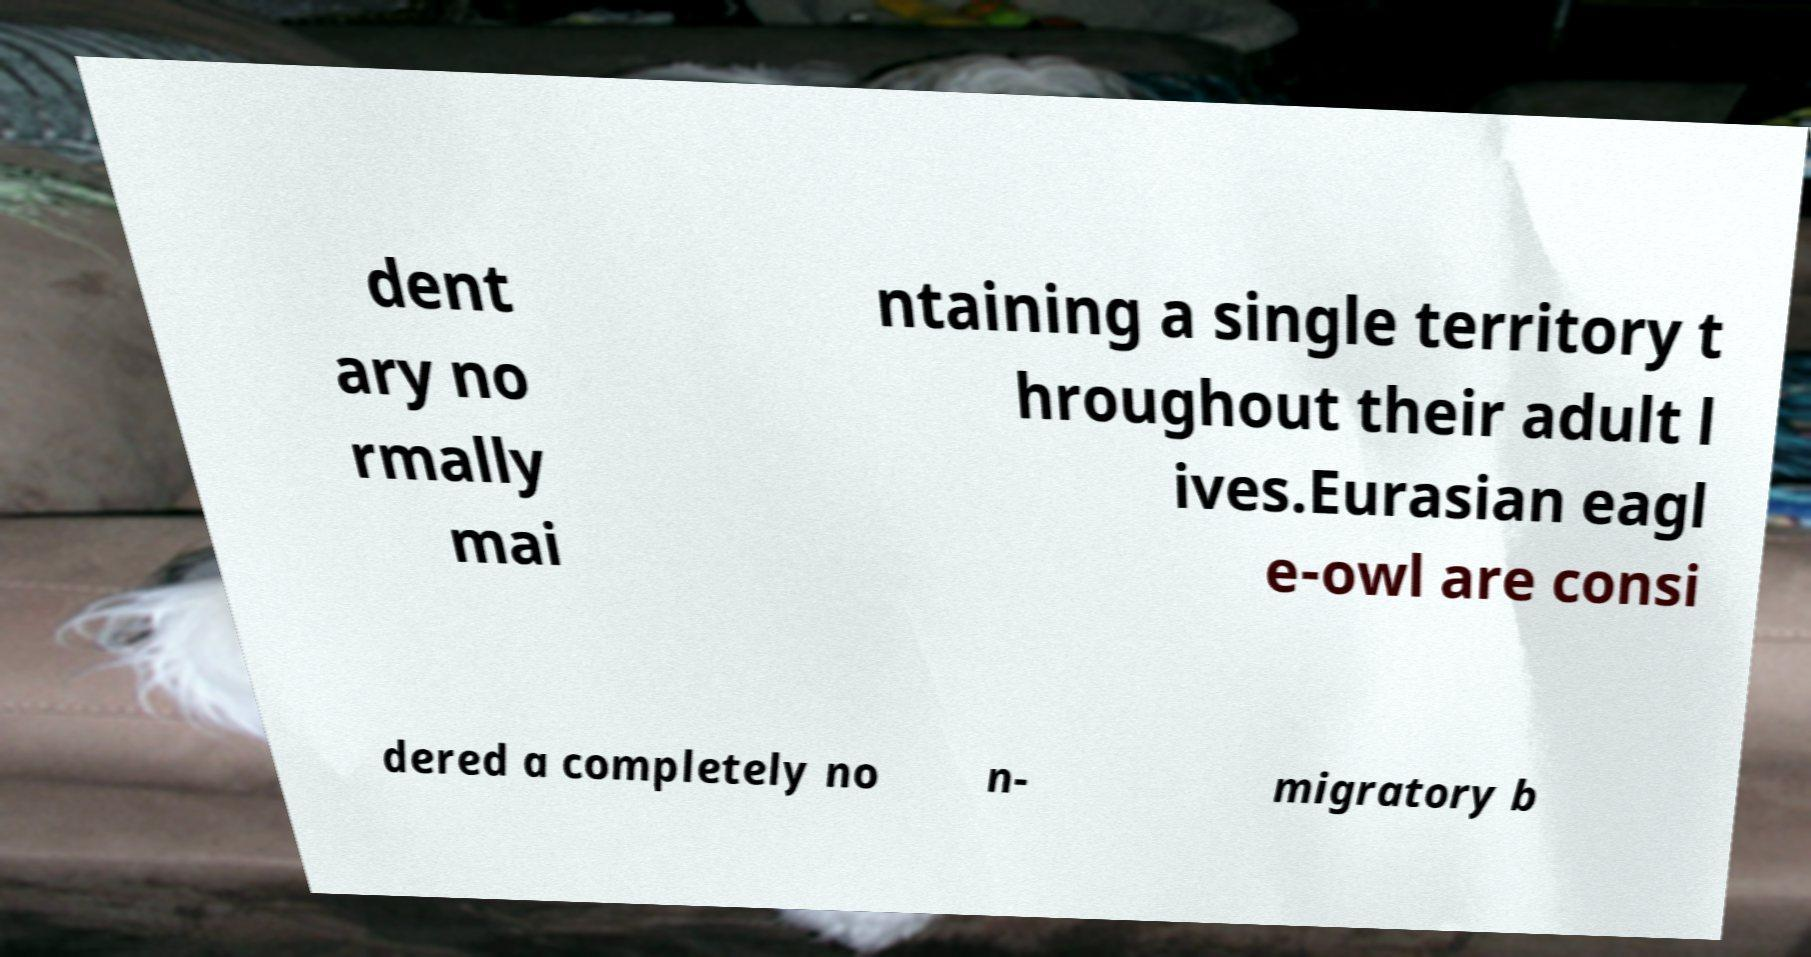What messages or text are displayed in this image? I need them in a readable, typed format. dent ary no rmally mai ntaining a single territory t hroughout their adult l ives.Eurasian eagl e-owl are consi dered a completely no n- migratory b 